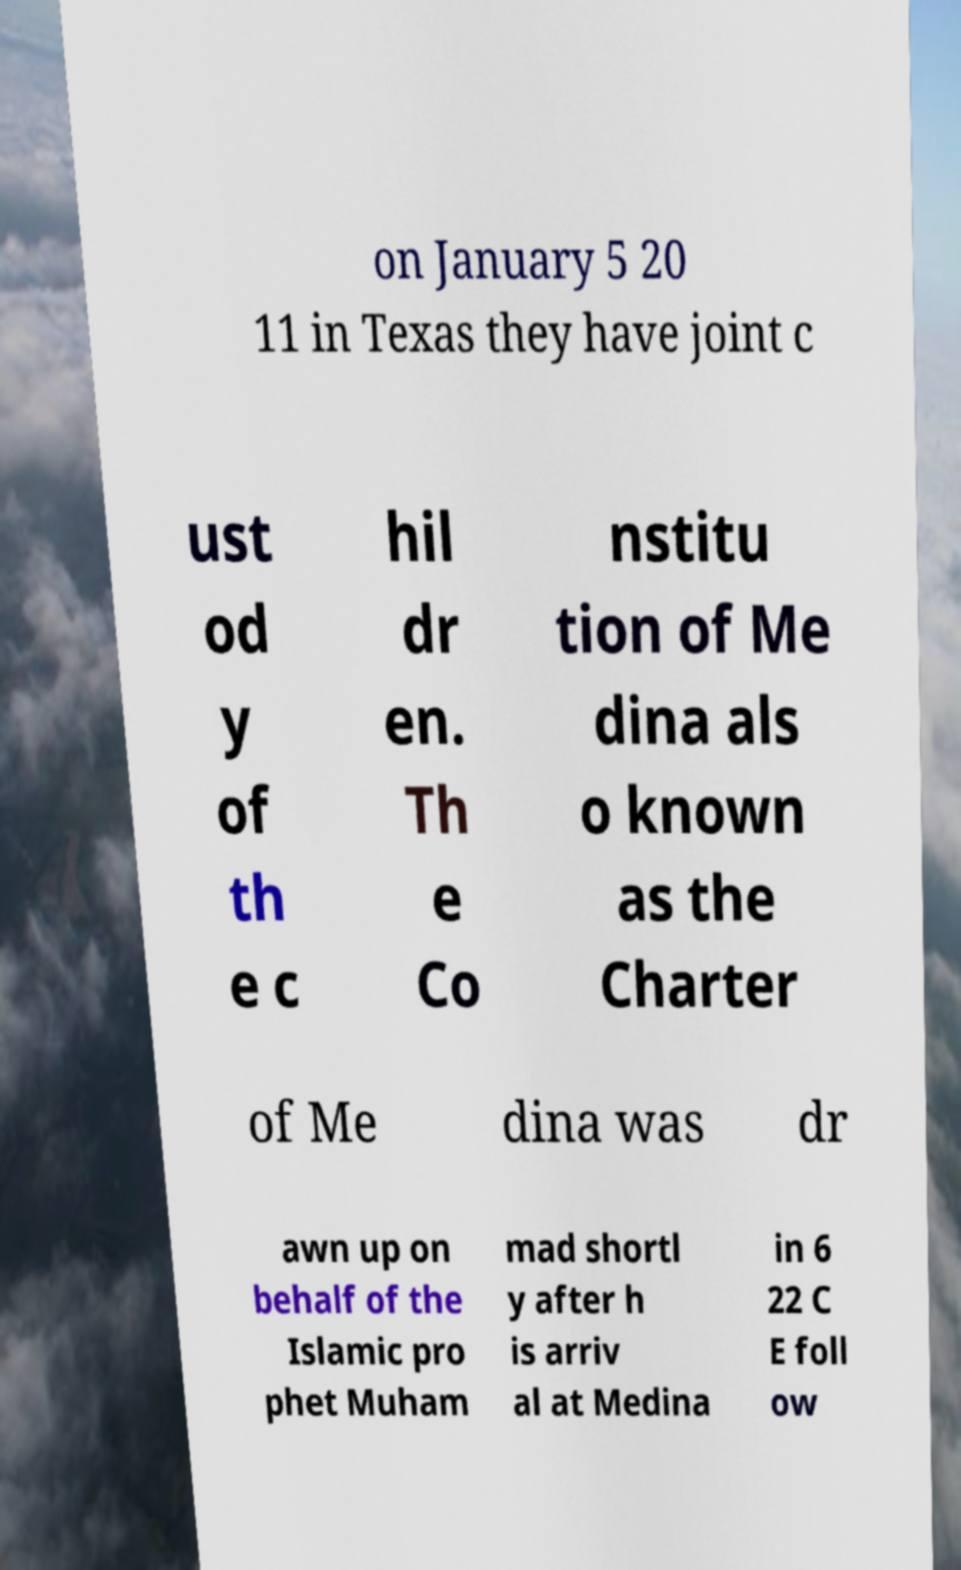Can you accurately transcribe the text from the provided image for me? on January 5 20 11 in Texas they have joint c ust od y of th e c hil dr en. Th e Co nstitu tion of Me dina als o known as the Charter of Me dina was dr awn up on behalf of the Islamic pro phet Muham mad shortl y after h is arriv al at Medina in 6 22 C E foll ow 